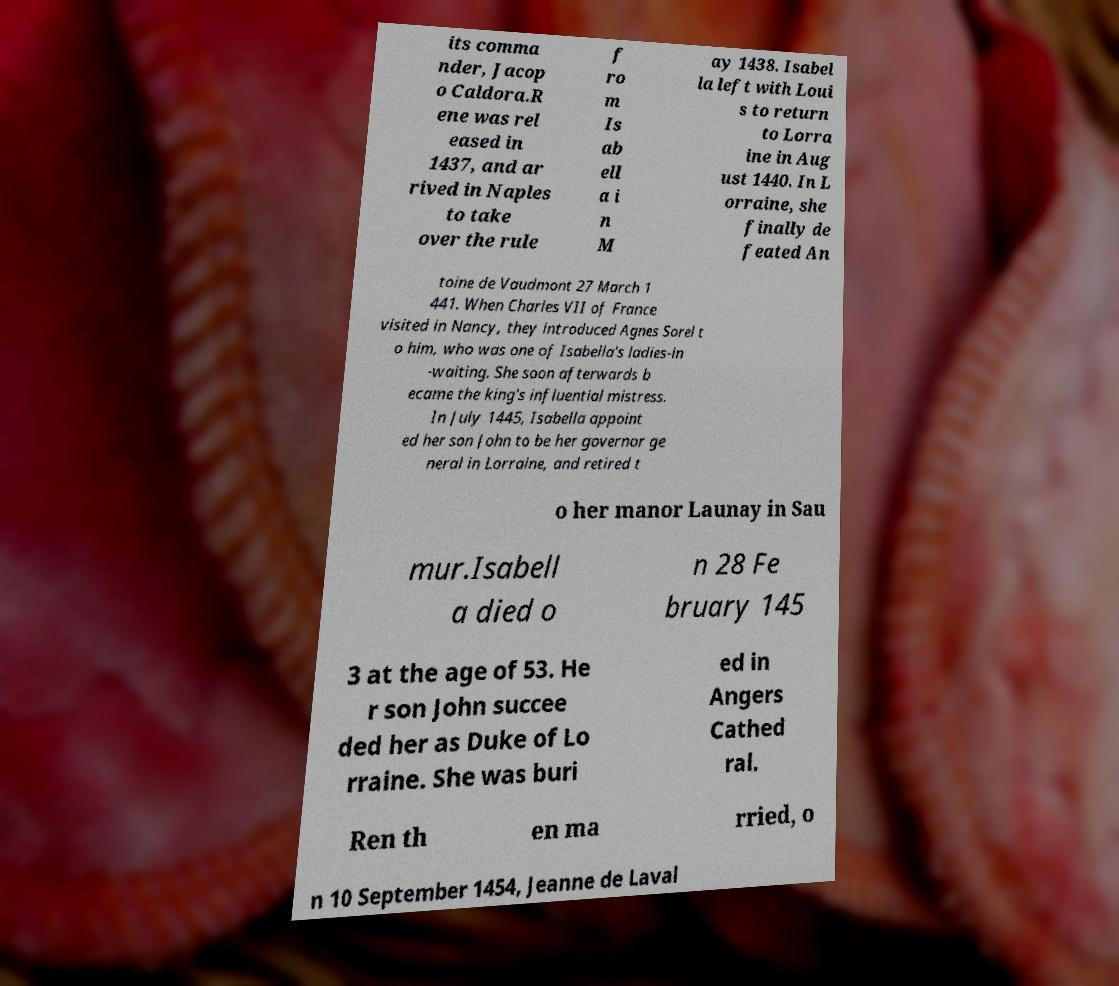Could you extract and type out the text from this image? its comma nder, Jacop o Caldora.R ene was rel eased in 1437, and ar rived in Naples to take over the rule f ro m Is ab ell a i n M ay 1438. Isabel la left with Loui s to return to Lorra ine in Aug ust 1440. In L orraine, she finally de feated An toine de Vaudmont 27 March 1 441. When Charles VII of France visited in Nancy, they introduced Agnes Sorel t o him, who was one of Isabella's ladies-in -waiting. She soon afterwards b ecame the king's influential mistress. In July 1445, Isabella appoint ed her son John to be her governor ge neral in Lorraine, and retired t o her manor Launay in Sau mur.Isabell a died o n 28 Fe bruary 145 3 at the age of 53. He r son John succee ded her as Duke of Lo rraine. She was buri ed in Angers Cathed ral. Ren th en ma rried, o n 10 September 1454, Jeanne de Laval 